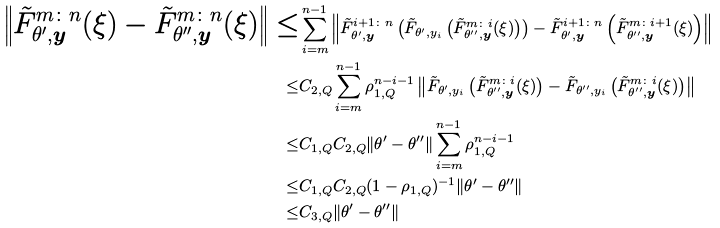<formula> <loc_0><loc_0><loc_500><loc_500>\left \| \tilde { F } _ { \theta ^ { \prime } , \boldsymbol y } ^ { m \colon n } ( \xi ) - \tilde { F } _ { \theta ^ { \prime \prime } , \boldsymbol y } ^ { m \colon n } ( \xi ) \right \| \leq & \sum _ { i = m } ^ { n - 1 } \left \| \tilde { F } _ { \theta ^ { \prime } , \boldsymbol y } ^ { i + 1 \colon n } \left ( \tilde { F } _ { \theta ^ { \prime } , y _ { i } } \left ( \tilde { F } _ { \theta ^ { \prime \prime } , \boldsymbol y } ^ { m \colon i } ( \xi ) \right ) \right ) - \tilde { F } _ { \theta ^ { \prime } , \boldsymbol y } ^ { i + 1 \colon n } \left ( \tilde { F } _ { \theta ^ { \prime \prime } , \boldsymbol y } ^ { m \colon i + 1 } ( \xi ) \right ) \right \| \\ \leq & C _ { 2 , Q } \sum _ { i = m } ^ { n - 1 } \rho _ { 1 , Q } ^ { n - i - 1 } \left \| \tilde { F } _ { \theta ^ { \prime } , y _ { i } } \left ( \tilde { F } _ { \theta ^ { \prime \prime } , \boldsymbol y } ^ { m \colon i } ( \xi ) \right ) - \tilde { F } _ { \theta ^ { \prime \prime } , y _ { i } } \left ( \tilde { F } _ { \theta ^ { \prime \prime } , \boldsymbol y } ^ { m \colon i } ( \xi ) \right ) \right \| \\ \leq & C _ { 1 , Q } C _ { 2 , Q } \| \theta ^ { \prime } - \theta ^ { \prime \prime } \| \sum _ { i = m } ^ { n - 1 } \rho _ { 1 , Q } ^ { n - i - 1 } \\ \leq & C _ { 1 , Q } C _ { 2 , Q } ( 1 - \rho _ { 1 , Q } ) ^ { - 1 } \| \theta ^ { \prime } - \theta ^ { \prime \prime } \| \\ \leq & C _ { 3 , Q } \| \theta ^ { \prime } - \theta ^ { \prime \prime } \|</formula> 